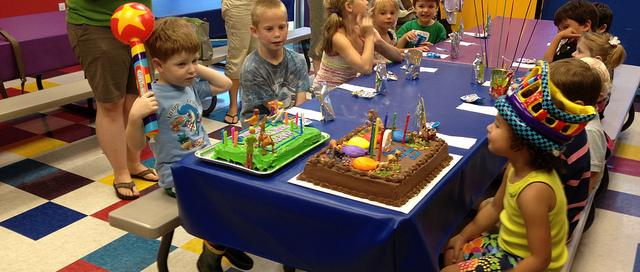Where is this party taking place? restaurant 